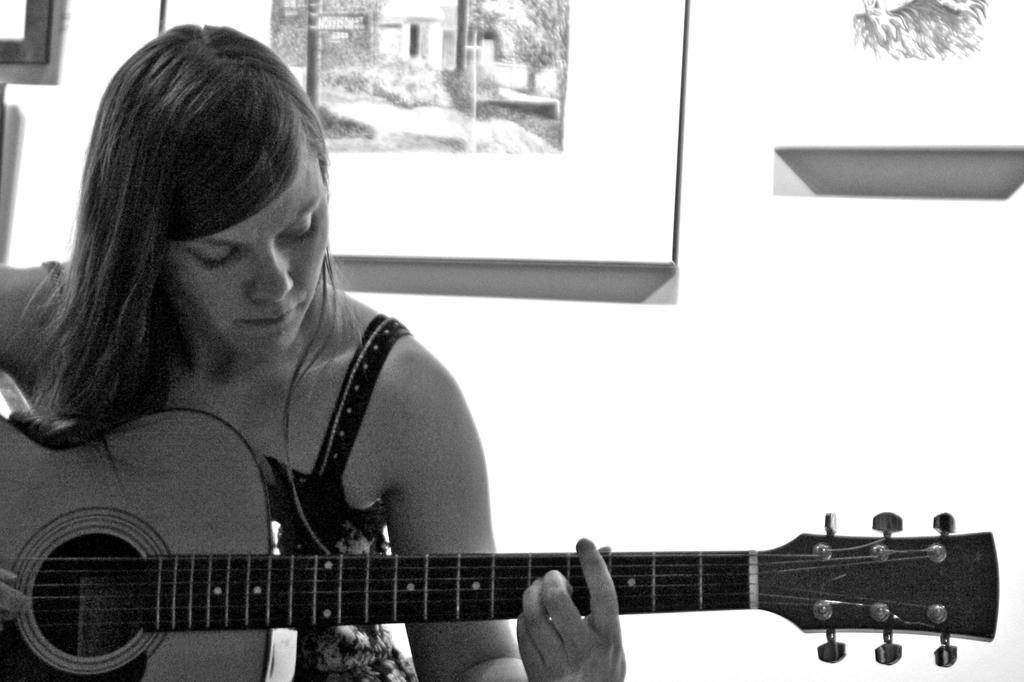Can you describe this image briefly? In this picture we can see a woman who is playing guitar. On the background we can see a frame. 